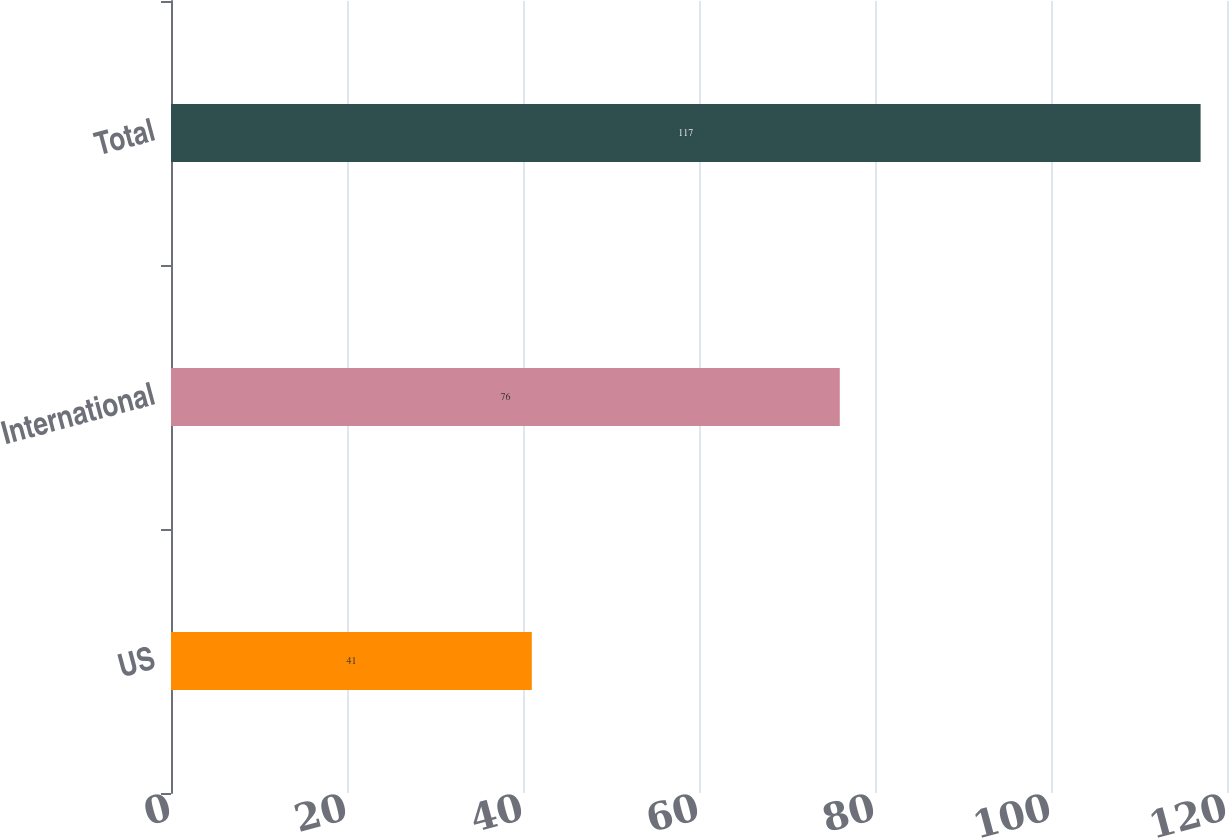Convert chart to OTSL. <chart><loc_0><loc_0><loc_500><loc_500><bar_chart><fcel>US<fcel>International<fcel>Total<nl><fcel>41<fcel>76<fcel>117<nl></chart> 